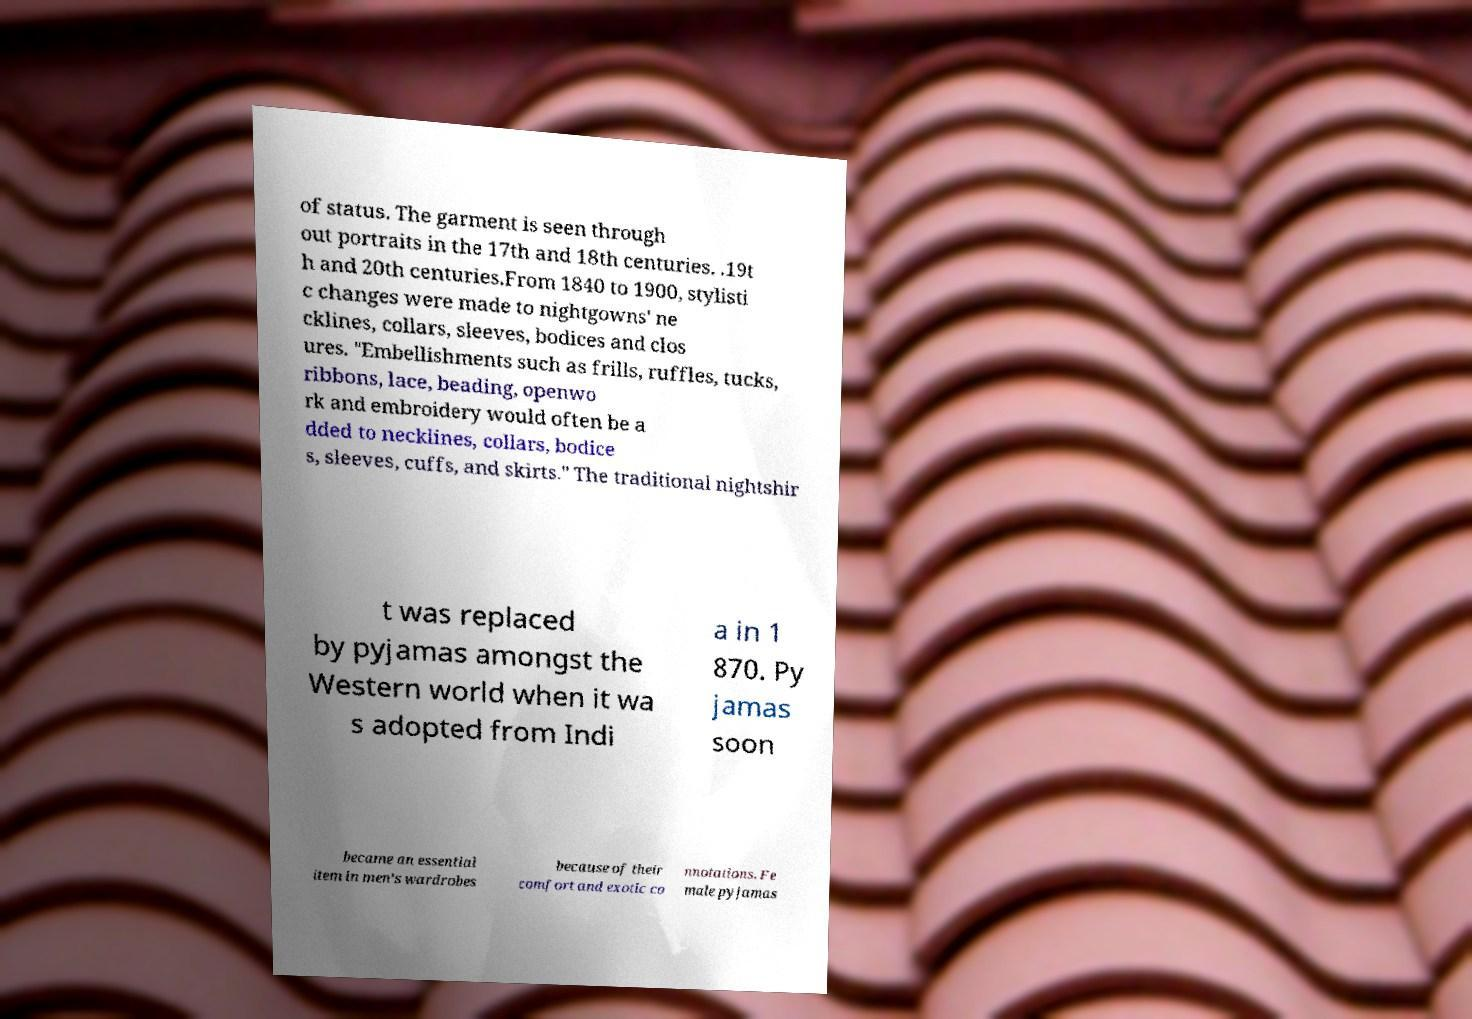Can you accurately transcribe the text from the provided image for me? of status. The garment is seen through out portraits in the 17th and 18th centuries. .19t h and 20th centuries.From 1840 to 1900, stylisti c changes were made to nightgowns' ne cklines, collars, sleeves, bodices and clos ures. "Embellishments such as frills, ruffles, tucks, ribbons, lace, beading, openwo rk and embroidery would often be a dded to necklines, collars, bodice s, sleeves, cuffs, and skirts." The traditional nightshir t was replaced by pyjamas amongst the Western world when it wa s adopted from Indi a in 1 870. Py jamas soon became an essential item in men's wardrobes because of their comfort and exotic co nnotations. Fe male pyjamas 